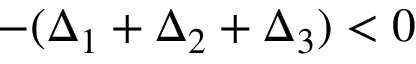<formula> <loc_0><loc_0><loc_500><loc_500>- ( \Delta _ { 1 } + \Delta _ { 2 } + \Delta _ { 3 } ) < 0</formula> 